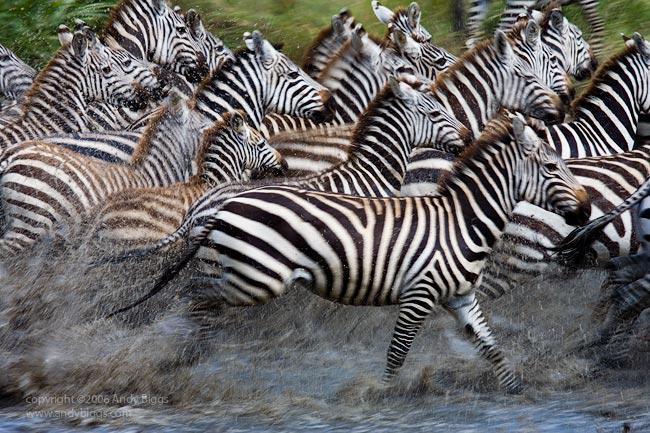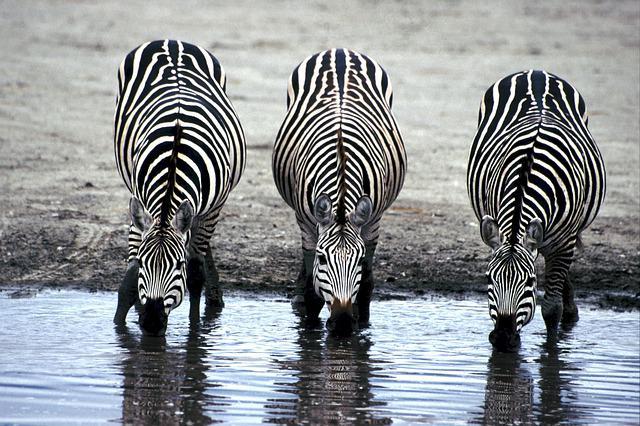The first image is the image on the left, the second image is the image on the right. For the images displayed, is the sentence "Both images show zebras standing in water." factually correct? Answer yes or no. Yes. The first image is the image on the left, the second image is the image on the right. Evaluate the accuracy of this statement regarding the images: "More than three zebras can be seen drinking water.". Is it true? Answer yes or no. No. 